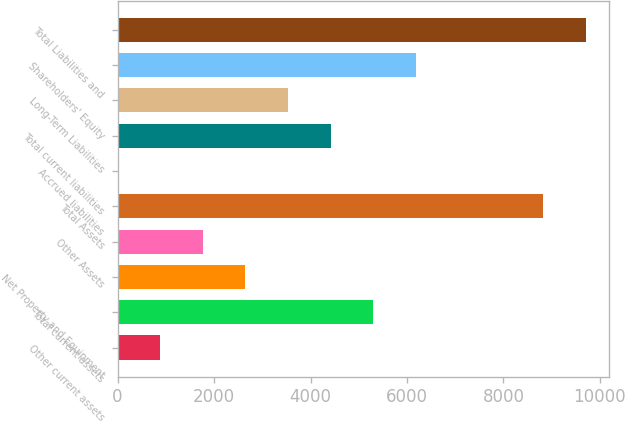Convert chart to OTSL. <chart><loc_0><loc_0><loc_500><loc_500><bar_chart><fcel>Other current assets<fcel>Total current assets<fcel>Net Property and Equipment<fcel>Other Assets<fcel>Total Assets<fcel>Accrued liabilities<fcel>Total current liabilities<fcel>Long-Term Liabilities<fcel>Shareholders' Equity<fcel>Total Liabilities and<nl><fcel>888.7<fcel>5297.2<fcel>2652.1<fcel>1770.4<fcel>8824<fcel>7<fcel>4415.5<fcel>3533.8<fcel>6178.9<fcel>9705.7<nl></chart> 